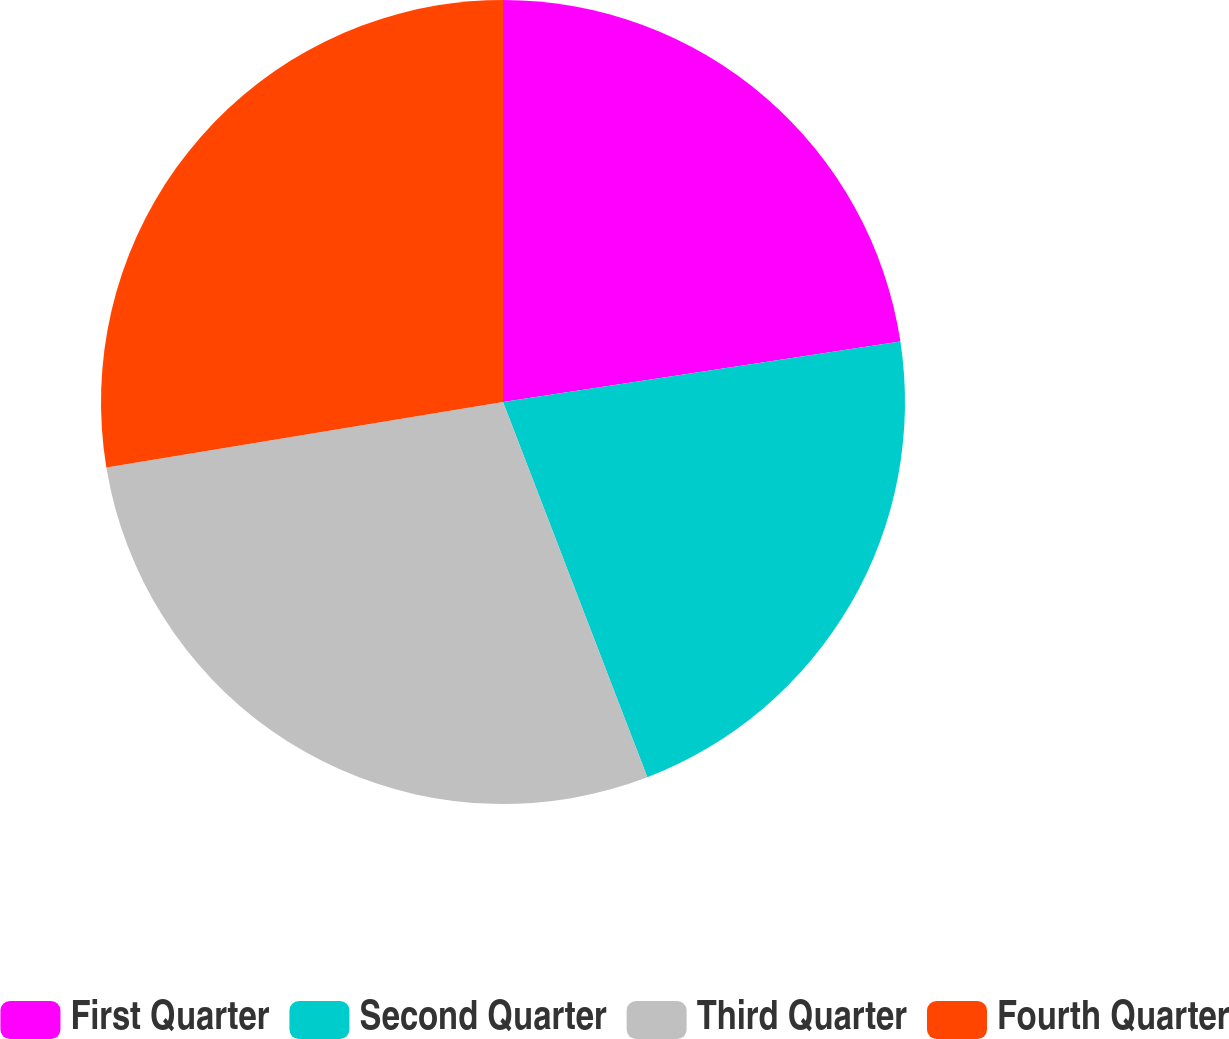<chart> <loc_0><loc_0><loc_500><loc_500><pie_chart><fcel>First Quarter<fcel>Second Quarter<fcel>Third Quarter<fcel>Fourth Quarter<nl><fcel>22.59%<fcel>21.56%<fcel>28.24%<fcel>27.6%<nl></chart> 